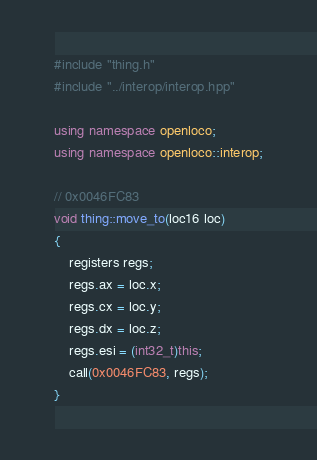Convert code to text. <code><loc_0><loc_0><loc_500><loc_500><_C++_>#include "thing.h"
#include "../interop/interop.hpp"

using namespace openloco;
using namespace openloco::interop;

// 0x0046FC83
void thing::move_to(loc16 loc)
{
    registers regs;
    regs.ax = loc.x;
    regs.cx = loc.y;
    regs.dx = loc.z;
    regs.esi = (int32_t)this;
    call(0x0046FC83, regs);
}
</code> 